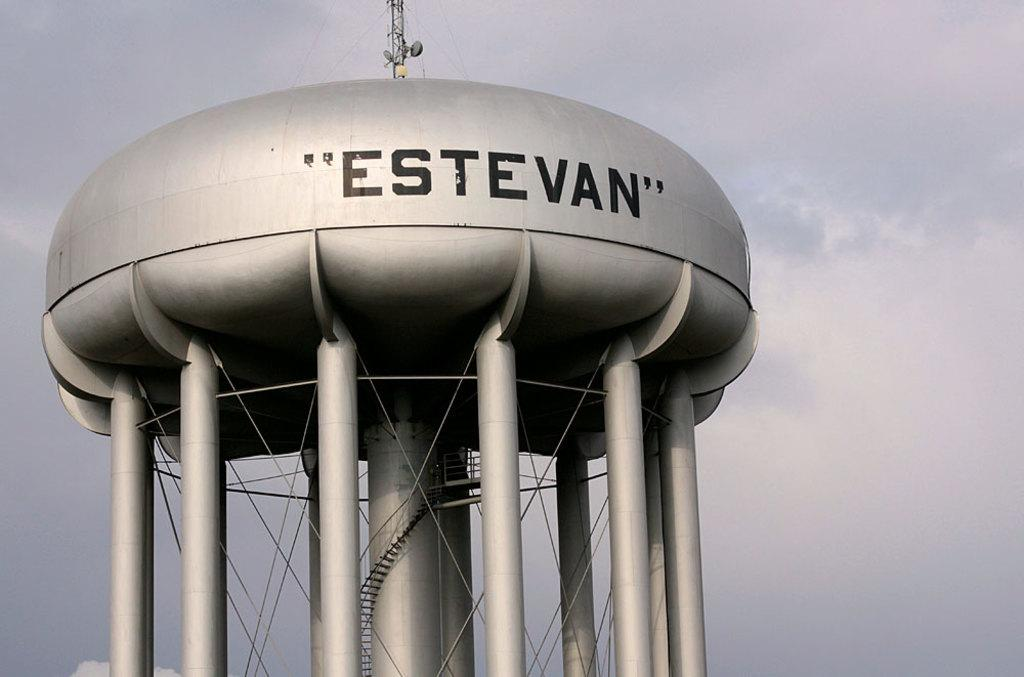<image>
Present a compact description of the photo's key features. A water tower with the word Estevan written on it 